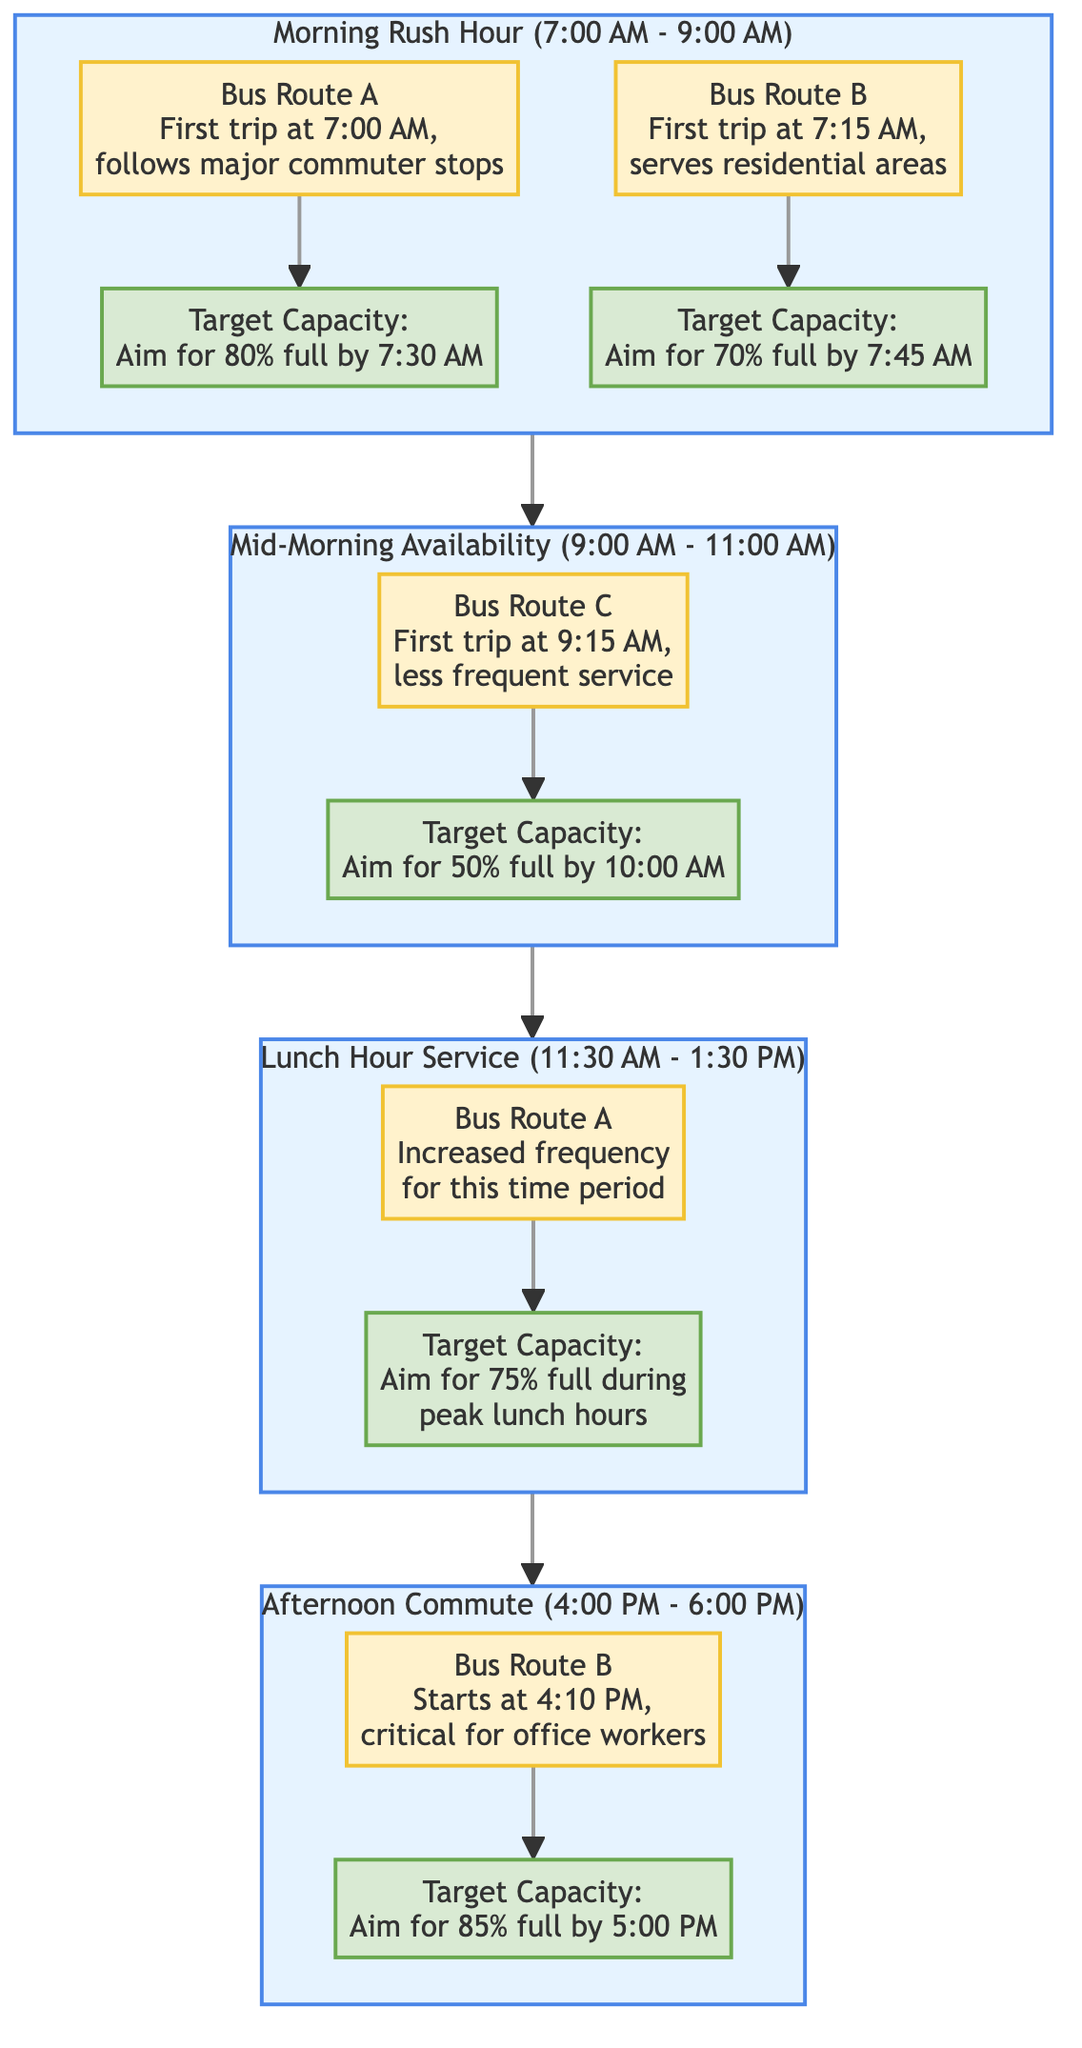What is the first bus route during the morning rush hour? The diagram indicates that during the morning rush hour, Bus Route A is the first bus route, starting at 7:00 AM.
Answer: Bus Route A What is the target capacity for Bus Route B during the morning rush hour? According to the diagram, Bus Route B aims for a target capacity of 70% full by 7:45 AM during the morning rush hour.
Answer: 70% How many bus routes are there in the lunch hour service? The lunch hour service section of the diagram shows only one bus route, which is Bus Route A.
Answer: 1 What is the timeframe for the mid-morning availability? The diagram defines the timeframe for mid-morning availability as 9:00 AM to 11:00 AM.
Answer: 9:00 AM to 11:00 AM Which bus route has an increased frequency during the lunch hour service? The diagram specifies that Bus Route A has increased frequency for the lunch hour service between 11:30 AM and 1:30 PM.
Answer: Bus Route A What is the aim for target capacity during the afternoon commute? The afternoon commute section of the diagram specifies that the aim is for Bus Route B to be 85% full by 5:00 PM.
Answer: 85% What is the relationship between mid-morning availability and lunch hour service? The diagram shows that mid-morning availability directly leads to the lunch hour service in a sequential flow.
Answer: Sequential flow What time does Bus Route C first depart? The mid-morning availability section states that Bus Route C has its first trip at 9:15 AM.
Answer: 9:15 AM What is the connection between morning rush hour and mid-morning availability? The diagram illustrates that morning rush hour precedes mid-morning availability, indicating a flow from one to the next.
Answer: Precedes 